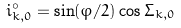Convert formula to latex. <formula><loc_0><loc_0><loc_500><loc_500>i _ { k , 0 } ^ { \circ } = \sin ( \varphi / 2 ) \cos \Sigma _ { k , 0 }</formula> 